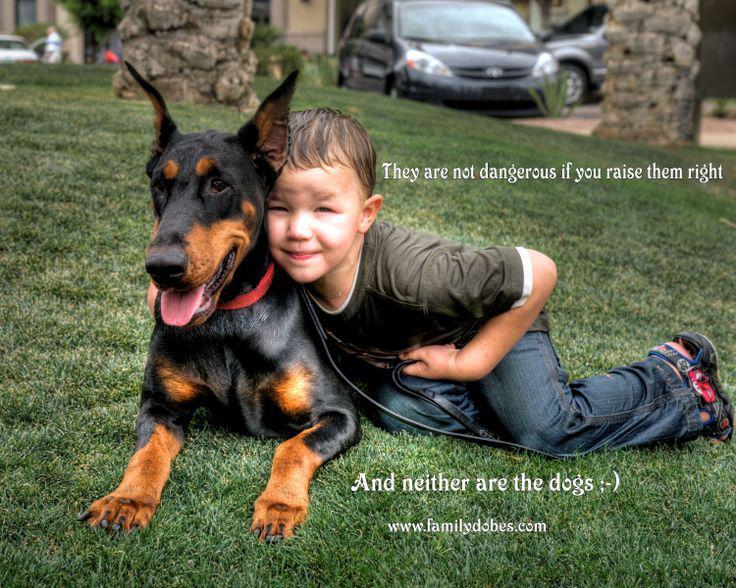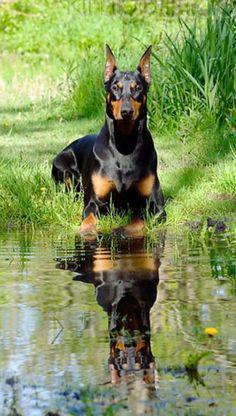The first image is the image on the left, the second image is the image on the right. Evaluate the accuracy of this statement regarding the images: "The left and right image contains the same number of dogs.". Is it true? Answer yes or no. Yes. The first image is the image on the left, the second image is the image on the right. Examine the images to the left and right. Is the description "The left image shows an open-mouthed doberman reclining on the grass by a young 'creature' of some type." accurate? Answer yes or no. Yes. 